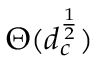Convert formula to latex. <formula><loc_0><loc_0><loc_500><loc_500>\Theta ( d _ { c } ^ { \frac { 1 } { 2 } } )</formula> 